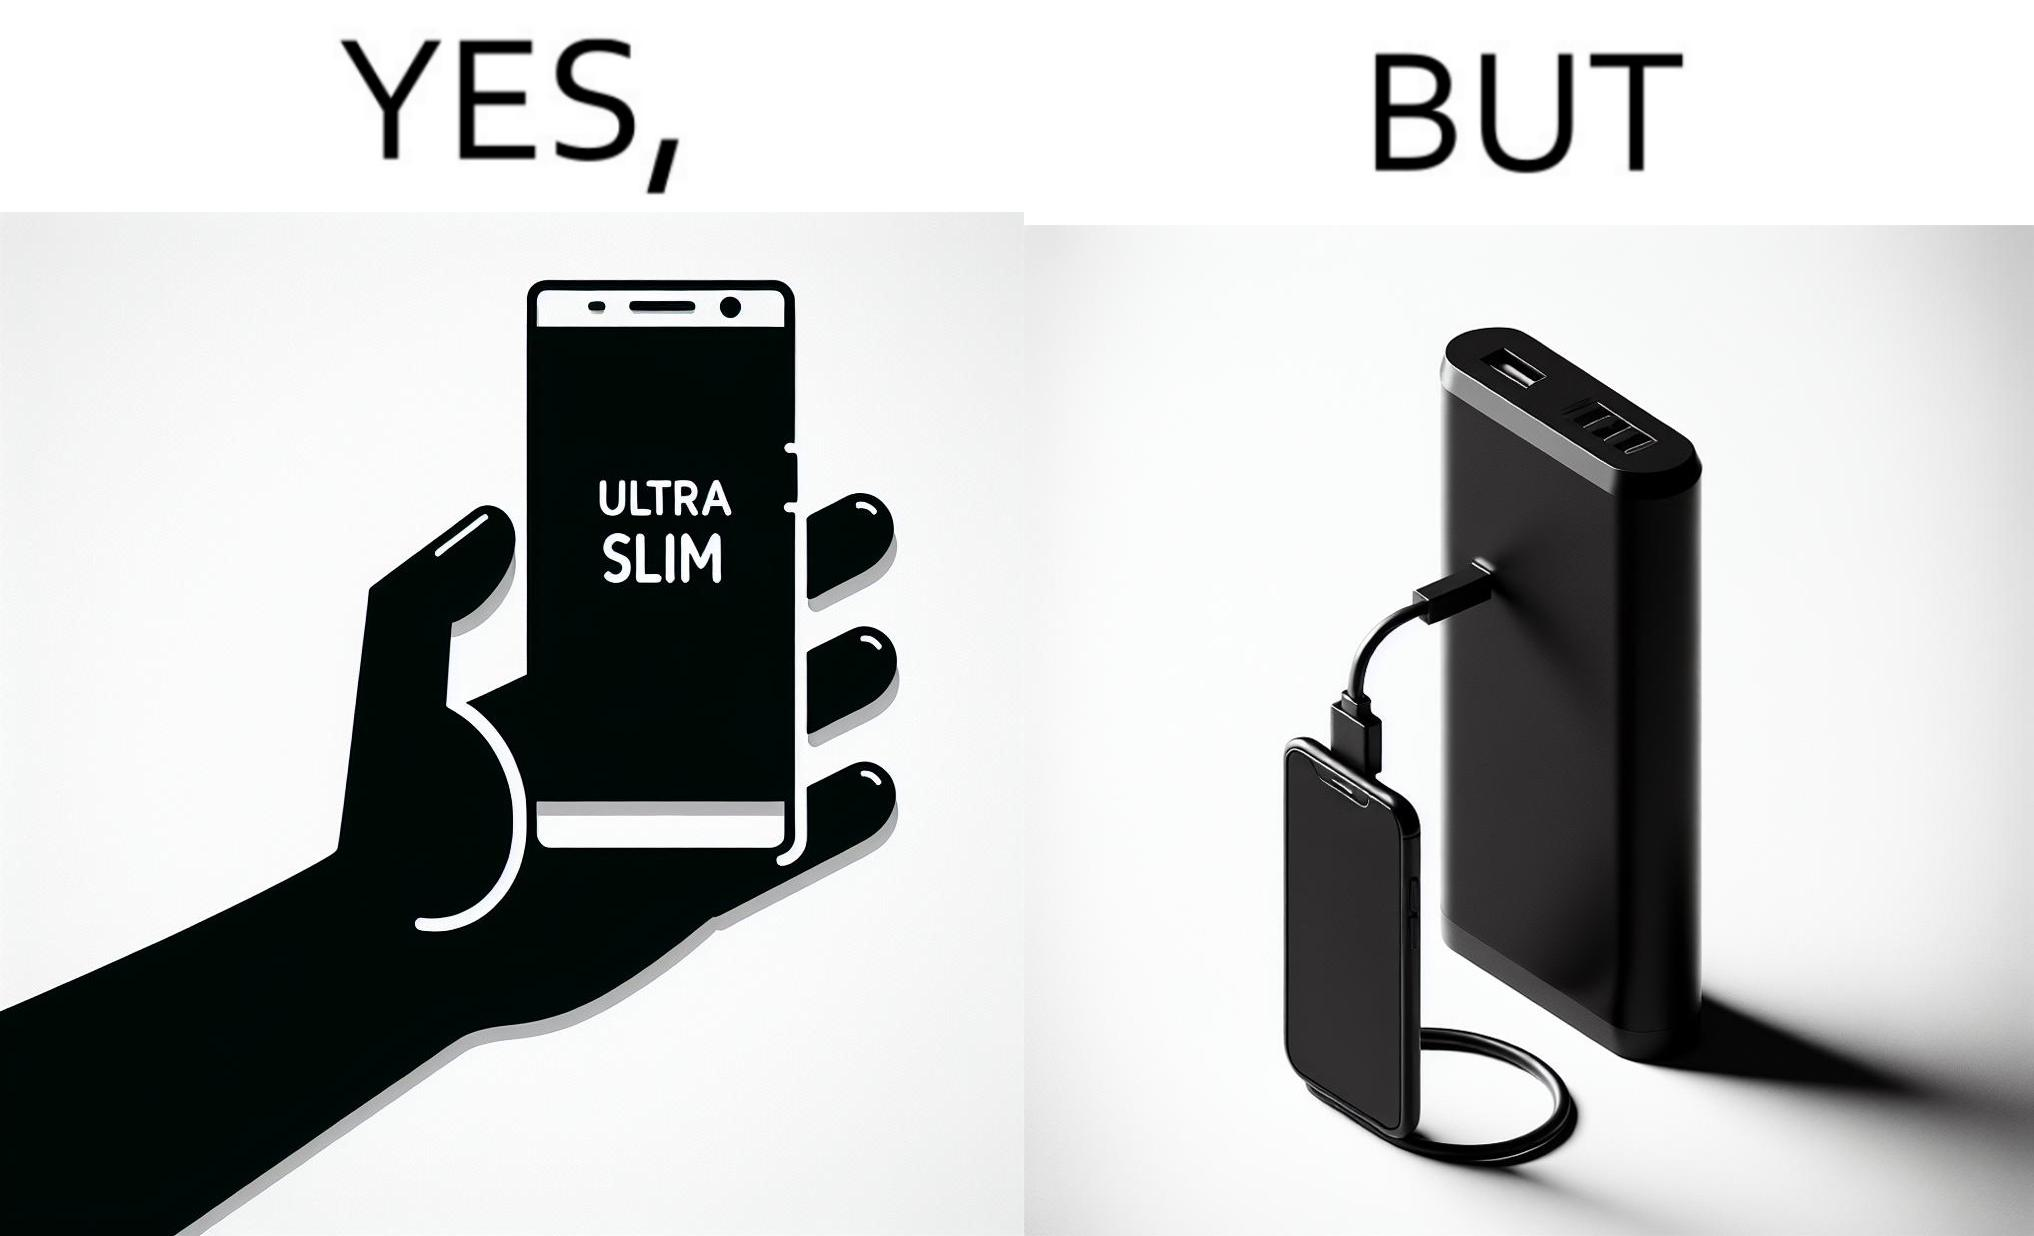Describe the content of this image. The image is satirical because even though the mobile phone has been developed to be very slim, it requires frequent recharging which makes the mobile phone useless without a big, heavy and thick power bank. 